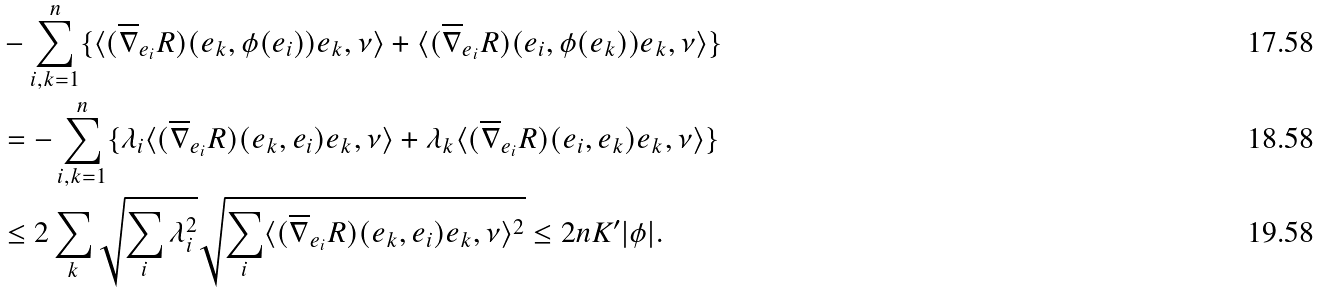Convert formula to latex. <formula><loc_0><loc_0><loc_500><loc_500>& - \sum _ { i , k = 1 } ^ { n } \{ \langle ( \overline { \nabla } _ { e _ { i } } R ) ( e _ { k } , \phi ( e _ { i } ) ) e _ { k } , \nu \rangle + \langle ( \overline { \nabla } _ { e _ { i } } R ) ( e _ { i } , \phi ( e _ { k } ) ) e _ { k } , \nu \rangle \} \\ & = - \sum _ { i , k = 1 } ^ { n } \{ \lambda _ { i } \langle ( \overline { \nabla } _ { e _ { i } } R ) ( e _ { k } , e _ { i } ) e _ { k } , \nu \rangle + \lambda _ { k } \langle ( \overline { \nabla } _ { e _ { i } } R ) ( e _ { i } , e _ { k } ) e _ { k } , \nu \rangle \} \\ & \leq 2 \sum _ { k } \sqrt { \sum _ { i } \lambda _ { i } ^ { 2 } } \sqrt { \sum _ { i } \langle ( \overline { \nabla } _ { e _ { i } } R ) ( e _ { k } , e _ { i } ) e _ { k } , \nu \rangle ^ { 2 } } \leq 2 n K ^ { \prime } | \phi | .</formula> 